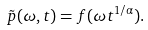<formula> <loc_0><loc_0><loc_500><loc_500>\tilde { p } ( \omega , t ) = f ( \omega t ^ { 1 / \alpha } ) .</formula> 